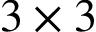<formula> <loc_0><loc_0><loc_500><loc_500>3 \times 3</formula> 